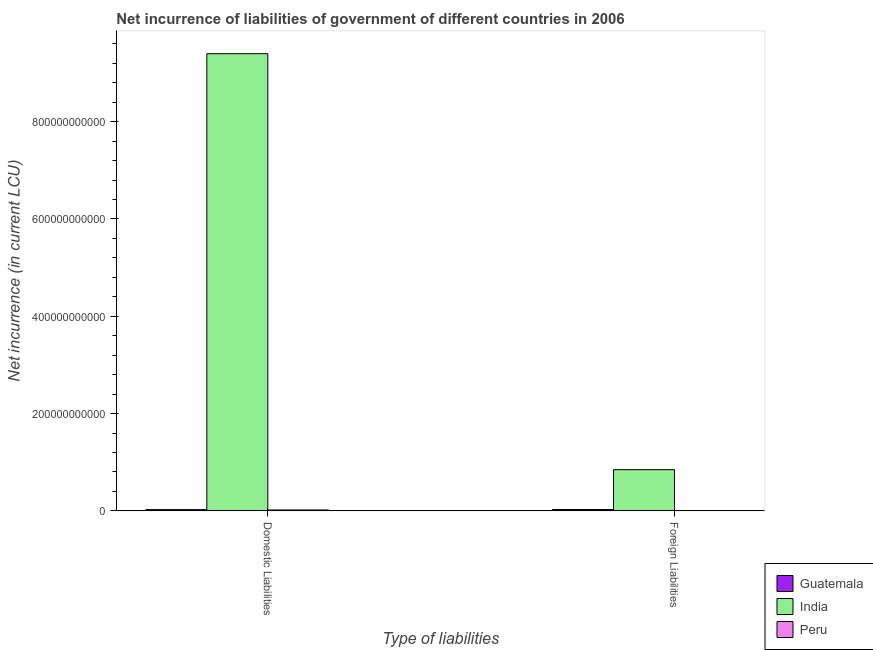How many groups of bars are there?
Offer a very short reply. 2. How many bars are there on the 1st tick from the left?
Make the answer very short. 3. How many bars are there on the 1st tick from the right?
Provide a short and direct response. 2. What is the label of the 1st group of bars from the left?
Provide a succinct answer. Domestic Liabilities. What is the net incurrence of domestic liabilities in Guatemala?
Your response must be concise. 2.60e+09. Across all countries, what is the maximum net incurrence of foreign liabilities?
Your answer should be compact. 8.47e+1. Across all countries, what is the minimum net incurrence of domestic liabilities?
Your response must be concise. 1.92e+09. What is the total net incurrence of foreign liabilities in the graph?
Your answer should be very brief. 8.76e+1. What is the difference between the net incurrence of domestic liabilities in Peru and that in India?
Your answer should be very brief. -9.38e+11. What is the difference between the net incurrence of foreign liabilities in India and the net incurrence of domestic liabilities in Peru?
Offer a very short reply. 8.28e+1. What is the average net incurrence of domestic liabilities per country?
Give a very brief answer. 3.15e+11. What is the difference between the net incurrence of foreign liabilities and net incurrence of domestic liabilities in India?
Keep it short and to the point. -8.55e+11. What is the ratio of the net incurrence of domestic liabilities in Peru to that in India?
Provide a succinct answer. 0. Is the net incurrence of domestic liabilities in Peru less than that in India?
Provide a succinct answer. Yes. In how many countries, is the net incurrence of domestic liabilities greater than the average net incurrence of domestic liabilities taken over all countries?
Keep it short and to the point. 1. Are all the bars in the graph horizontal?
Keep it short and to the point. No. What is the difference between two consecutive major ticks on the Y-axis?
Ensure brevity in your answer.  2.00e+11. Where does the legend appear in the graph?
Give a very brief answer. Bottom right. How many legend labels are there?
Offer a very short reply. 3. How are the legend labels stacked?
Your response must be concise. Vertical. What is the title of the graph?
Provide a short and direct response. Net incurrence of liabilities of government of different countries in 2006. What is the label or title of the X-axis?
Provide a succinct answer. Type of liabilities. What is the label or title of the Y-axis?
Your answer should be compact. Net incurrence (in current LCU). What is the Net incurrence (in current LCU) of Guatemala in Domestic Liabilities?
Give a very brief answer. 2.60e+09. What is the Net incurrence (in current LCU) in India in Domestic Liabilities?
Offer a very short reply. 9.40e+11. What is the Net incurrence (in current LCU) of Peru in Domestic Liabilities?
Give a very brief answer. 1.92e+09. What is the Net incurrence (in current LCU) of Guatemala in Foreign Liabilities?
Provide a succinct answer. 2.87e+09. What is the Net incurrence (in current LCU) of India in Foreign Liabilities?
Ensure brevity in your answer.  8.47e+1. What is the Net incurrence (in current LCU) of Peru in Foreign Liabilities?
Offer a very short reply. 0. Across all Type of liabilities, what is the maximum Net incurrence (in current LCU) in Guatemala?
Offer a very short reply. 2.87e+09. Across all Type of liabilities, what is the maximum Net incurrence (in current LCU) of India?
Give a very brief answer. 9.40e+11. Across all Type of liabilities, what is the maximum Net incurrence (in current LCU) in Peru?
Provide a succinct answer. 1.92e+09. Across all Type of liabilities, what is the minimum Net incurrence (in current LCU) in Guatemala?
Provide a succinct answer. 2.60e+09. Across all Type of liabilities, what is the minimum Net incurrence (in current LCU) of India?
Your answer should be very brief. 8.47e+1. What is the total Net incurrence (in current LCU) of Guatemala in the graph?
Your response must be concise. 5.47e+09. What is the total Net incurrence (in current LCU) of India in the graph?
Your answer should be very brief. 1.02e+12. What is the total Net incurrence (in current LCU) of Peru in the graph?
Provide a succinct answer. 1.92e+09. What is the difference between the Net incurrence (in current LCU) in Guatemala in Domestic Liabilities and that in Foreign Liabilities?
Provide a succinct answer. -2.63e+08. What is the difference between the Net incurrence (in current LCU) of India in Domestic Liabilities and that in Foreign Liabilities?
Keep it short and to the point. 8.55e+11. What is the difference between the Net incurrence (in current LCU) of Guatemala in Domestic Liabilities and the Net incurrence (in current LCU) of India in Foreign Liabilities?
Make the answer very short. -8.21e+1. What is the average Net incurrence (in current LCU) in Guatemala per Type of liabilities?
Ensure brevity in your answer.  2.74e+09. What is the average Net incurrence (in current LCU) of India per Type of liabilities?
Your answer should be compact. 5.12e+11. What is the average Net incurrence (in current LCU) in Peru per Type of liabilities?
Give a very brief answer. 9.58e+08. What is the difference between the Net incurrence (in current LCU) of Guatemala and Net incurrence (in current LCU) of India in Domestic Liabilities?
Give a very brief answer. -9.37e+11. What is the difference between the Net incurrence (in current LCU) in Guatemala and Net incurrence (in current LCU) in Peru in Domestic Liabilities?
Give a very brief answer. 6.88e+08. What is the difference between the Net incurrence (in current LCU) in India and Net incurrence (in current LCU) in Peru in Domestic Liabilities?
Your answer should be very brief. 9.38e+11. What is the difference between the Net incurrence (in current LCU) in Guatemala and Net incurrence (in current LCU) in India in Foreign Liabilities?
Give a very brief answer. -8.19e+1. What is the ratio of the Net incurrence (in current LCU) of Guatemala in Domestic Liabilities to that in Foreign Liabilities?
Give a very brief answer. 0.91. What is the ratio of the Net incurrence (in current LCU) in India in Domestic Liabilities to that in Foreign Liabilities?
Give a very brief answer. 11.09. What is the difference between the highest and the second highest Net incurrence (in current LCU) in Guatemala?
Your response must be concise. 2.63e+08. What is the difference between the highest and the second highest Net incurrence (in current LCU) of India?
Make the answer very short. 8.55e+11. What is the difference between the highest and the lowest Net incurrence (in current LCU) in Guatemala?
Make the answer very short. 2.63e+08. What is the difference between the highest and the lowest Net incurrence (in current LCU) in India?
Keep it short and to the point. 8.55e+11. What is the difference between the highest and the lowest Net incurrence (in current LCU) of Peru?
Offer a terse response. 1.92e+09. 